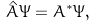Convert formula to latex. <formula><loc_0><loc_0><loc_500><loc_500>\hat { A } \Psi = A ^ { * } \Psi ,</formula> 